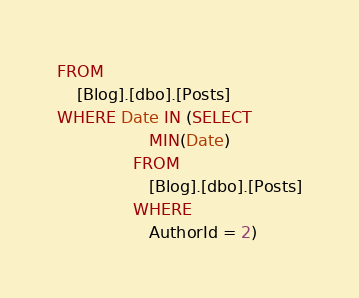<code> <loc_0><loc_0><loc_500><loc_500><_SQL_>FROM
    [Blog].[dbo].[Posts]
WHERE Date IN (SELECT
                  MIN(Date)
               FROM
                  [Blog].[dbo].[Posts]
               WHERE
                  AuthorId = 2)</code> 